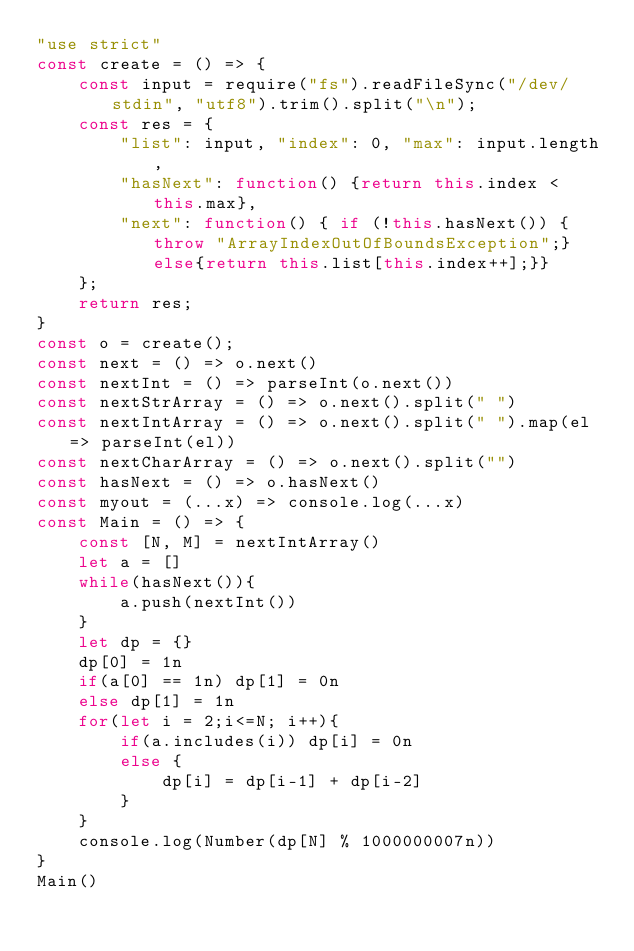<code> <loc_0><loc_0><loc_500><loc_500><_JavaScript_>"use strict"
const create = () => {
    const input = require("fs").readFileSync("/dev/stdin", "utf8").trim().split("\n");
    const res = {
        "list": input, "index": 0, "max": input.length,
        "hasNext": function() {return this.index < this.max},
        "next": function() { if (!this.hasNext()) {throw "ArrayIndexOutOfBoundsException";}else{return this.list[this.index++];}}
    };
    return res;
}
const o = create();
const next = () => o.next()
const nextInt = () => parseInt(o.next())
const nextStrArray = () => o.next().split(" ")
const nextIntArray = () => o.next().split(" ").map(el => parseInt(el))
const nextCharArray = () => o.next().split("")
const hasNext = () => o.hasNext()
const myout = (...x) => console.log(...x)
const Main = () => {
    const [N, M] = nextIntArray()
    let a = []
    while(hasNext()){
        a.push(nextInt())
    }
    let dp = {}
    dp[0] = 1n
    if(a[0] == 1n) dp[1] = 0n
    else dp[1] = 1n
    for(let i = 2;i<=N; i++){
        if(a.includes(i)) dp[i] = 0n
        else {
            dp[i] = dp[i-1] + dp[i-2]
        }        
    }
    console.log(Number(dp[N] % 1000000007n))
}
Main()
</code> 